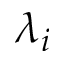Convert formula to latex. <formula><loc_0><loc_0><loc_500><loc_500>\lambda _ { i }</formula> 